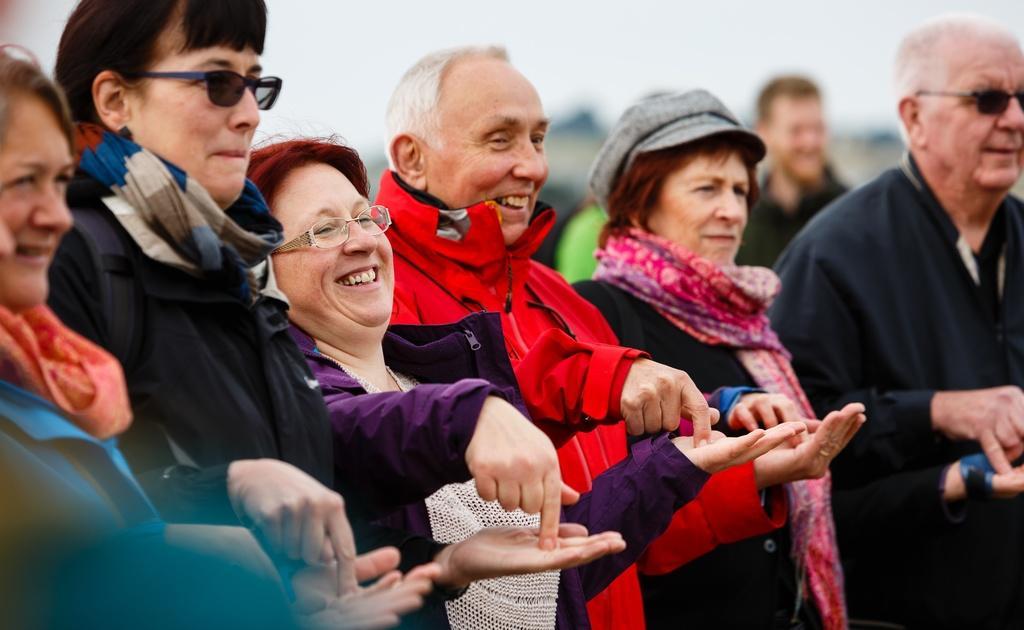In one or two sentences, can you explain what this image depicts? In this image we can see there are a few people standing with a smile. 